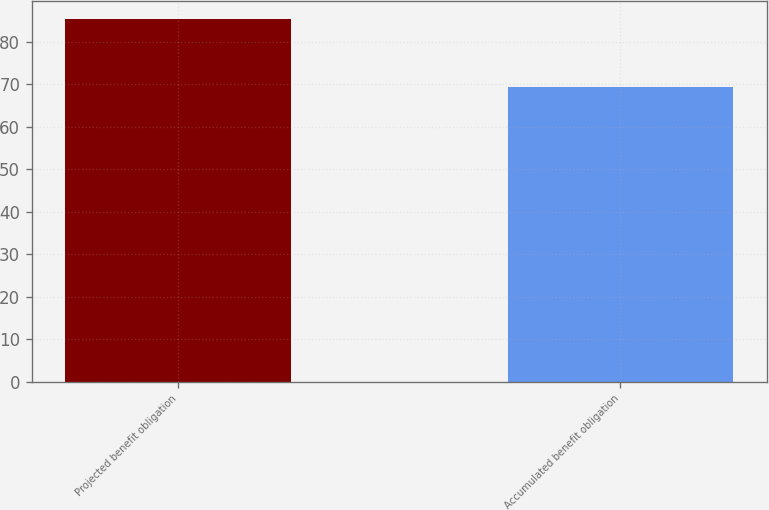Convert chart to OTSL. <chart><loc_0><loc_0><loc_500><loc_500><bar_chart><fcel>Projected benefit obligation<fcel>Accumulated benefit obligation<nl><fcel>85.3<fcel>69.4<nl></chart> 